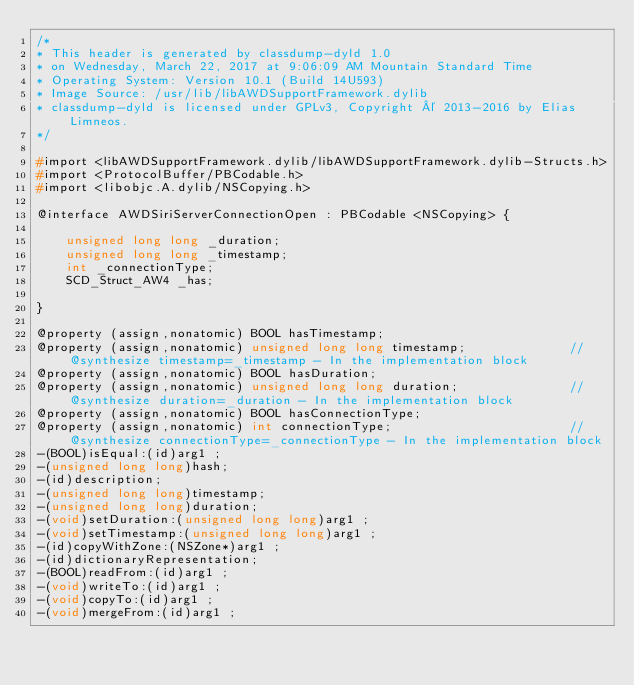Convert code to text. <code><loc_0><loc_0><loc_500><loc_500><_C_>/*
* This header is generated by classdump-dyld 1.0
* on Wednesday, March 22, 2017 at 9:06:09 AM Mountain Standard Time
* Operating System: Version 10.1 (Build 14U593)
* Image Source: /usr/lib/libAWDSupportFramework.dylib
* classdump-dyld is licensed under GPLv3, Copyright © 2013-2016 by Elias Limneos.
*/

#import <libAWDSupportFramework.dylib/libAWDSupportFramework.dylib-Structs.h>
#import <ProtocolBuffer/PBCodable.h>
#import <libobjc.A.dylib/NSCopying.h>

@interface AWDSiriServerConnectionOpen : PBCodable <NSCopying> {

	unsigned long long _duration;
	unsigned long long _timestamp;
	int _connectionType;
	SCD_Struct_AW4 _has;

}

@property (assign,nonatomic) BOOL hasTimestamp; 
@property (assign,nonatomic) unsigned long long timestamp;              //@synthesize timestamp=_timestamp - In the implementation block
@property (assign,nonatomic) BOOL hasDuration; 
@property (assign,nonatomic) unsigned long long duration;               //@synthesize duration=_duration - In the implementation block
@property (assign,nonatomic) BOOL hasConnectionType; 
@property (assign,nonatomic) int connectionType;                        //@synthesize connectionType=_connectionType - In the implementation block
-(BOOL)isEqual:(id)arg1 ;
-(unsigned long long)hash;
-(id)description;
-(unsigned long long)timestamp;
-(unsigned long long)duration;
-(void)setDuration:(unsigned long long)arg1 ;
-(void)setTimestamp:(unsigned long long)arg1 ;
-(id)copyWithZone:(NSZone*)arg1 ;
-(id)dictionaryRepresentation;
-(BOOL)readFrom:(id)arg1 ;
-(void)writeTo:(id)arg1 ;
-(void)copyTo:(id)arg1 ;
-(void)mergeFrom:(id)arg1 ;</code> 